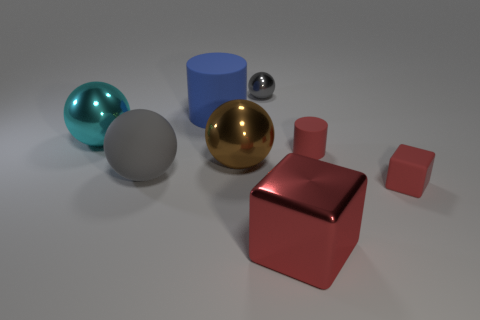Do the small block and the tiny cylinder have the same color?
Your answer should be very brief. Yes. How many other big rubber things are the same shape as the blue rubber thing?
Your answer should be very brief. 0. What number of large things have the same color as the tiny ball?
Offer a terse response. 1. There is a tiny red object that is behind the large matte sphere; is it the same shape as the big rubber object that is behind the tiny cylinder?
Offer a very short reply. Yes. There is a big rubber object on the right side of the gray thing that is to the left of the tiny shiny ball; how many large brown things are to the right of it?
Offer a very short reply. 1. There is a tiny object that is left of the red thing behind the gray sphere in front of the big rubber cylinder; what is its material?
Your answer should be very brief. Metal. Is the big sphere that is behind the brown ball made of the same material as the big brown thing?
Ensure brevity in your answer.  Yes. What number of objects have the same size as the red rubber cylinder?
Your answer should be compact. 2. Are there more large blue rubber cylinders on the right side of the small red matte cylinder than red metal objects that are left of the big blue thing?
Provide a short and direct response. No. Is there another blue object of the same shape as the big blue object?
Your answer should be very brief. No. 